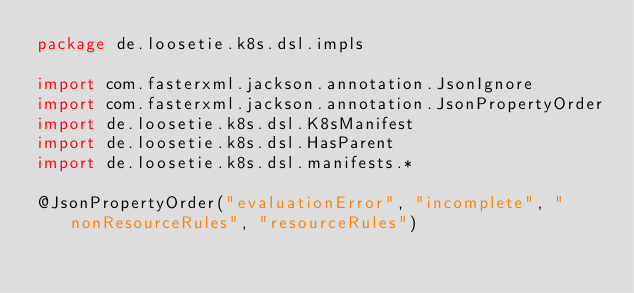<code> <loc_0><loc_0><loc_500><loc_500><_Kotlin_>package de.loosetie.k8s.dsl.impls

import com.fasterxml.jackson.annotation.JsonIgnore
import com.fasterxml.jackson.annotation.JsonPropertyOrder
import de.loosetie.k8s.dsl.K8sManifest
import de.loosetie.k8s.dsl.HasParent
import de.loosetie.k8s.dsl.manifests.*

@JsonPropertyOrder("evaluationError", "incomplete", "nonResourceRules", "resourceRules")</code> 